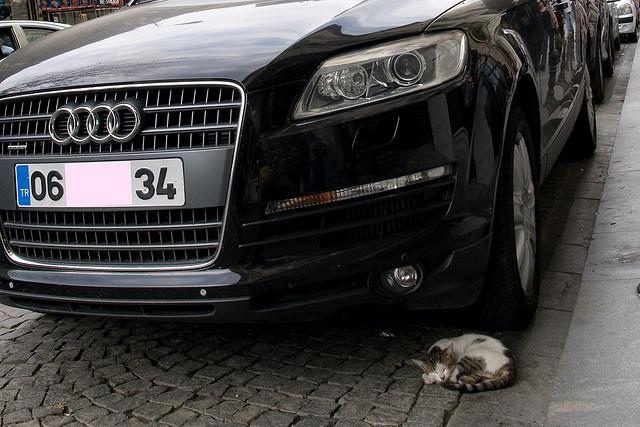What country is this car likely in?
Give a very brief answer. Germany. What color is the car?
Be succinct. Black. Is the cat about to be crushed?
Short answer required. No. Where are the rest of his license plate?
Give a very brief answer. On back. What make of car is this?
Concise answer only. Audi. What color is the cat?
Concise answer only. White and gray. Is the car new?
Keep it brief. Yes. Why is the cat sleeping near the car's wheel?
Concise answer only. Shade. Is the cat wearing a collar?
Answer briefly. No. 